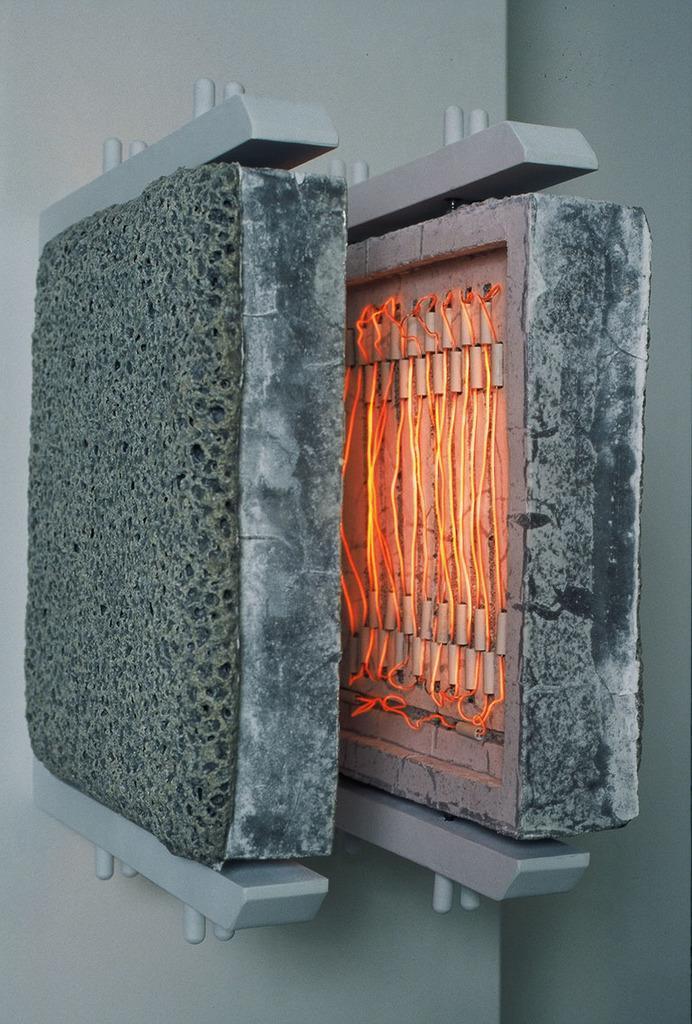Can you describe this image briefly? In the center of the image we can see two objects. On the left side, we can see one ash color object, which looks like a sponge. And on the right side object, we can see the wires are connected, which are in orange color. And we can see the metal round bars at the top and bottom of the objects. In the background there is a wall. 